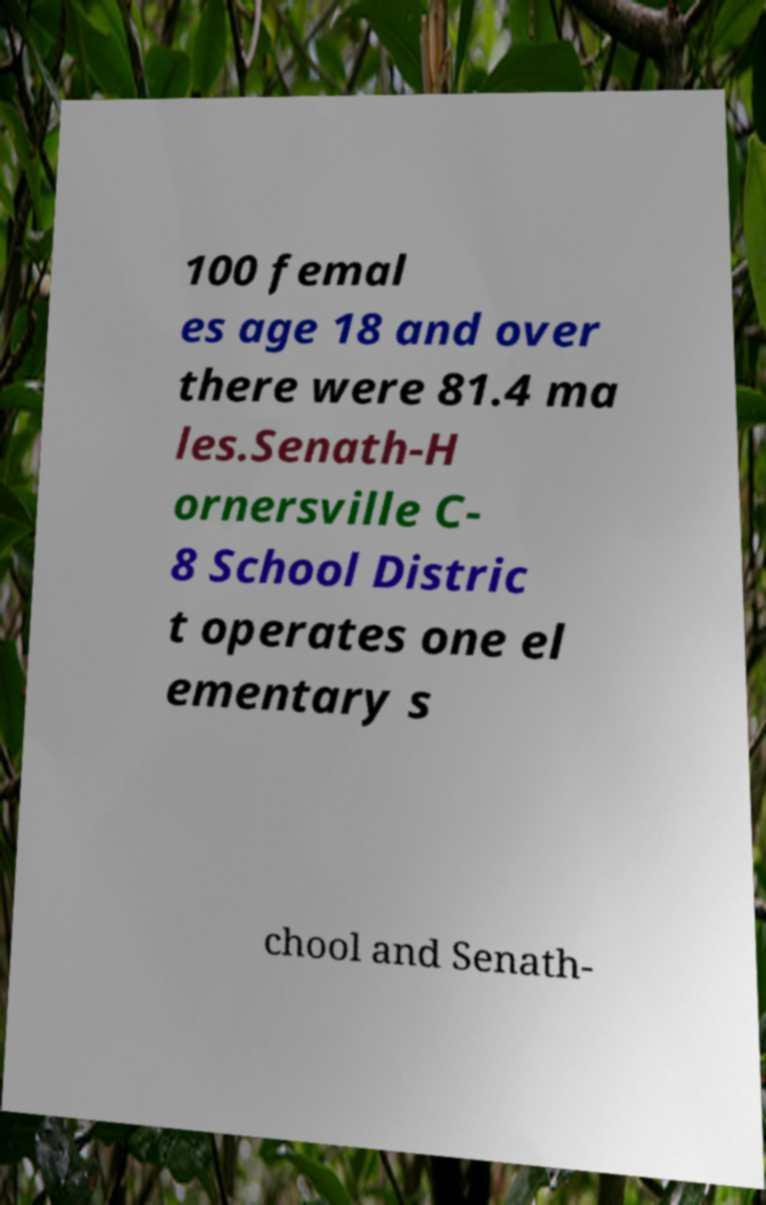Please identify and transcribe the text found in this image. 100 femal es age 18 and over there were 81.4 ma les.Senath-H ornersville C- 8 School Distric t operates one el ementary s chool and Senath- 